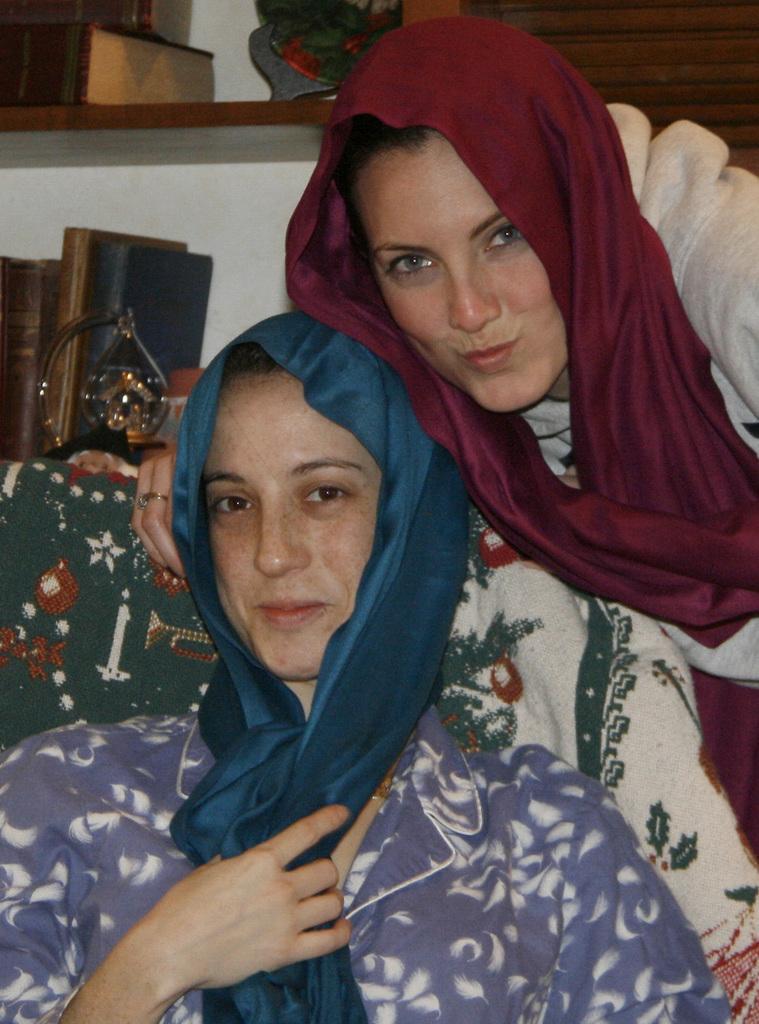In one or two sentences, can you explain what this image depicts? There is one woman sitting as we can see at the bottom of this image. There is one other woman sitting on the right side of this image. We can see the books and a wall in the background. 